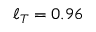Convert formula to latex. <formula><loc_0><loc_0><loc_500><loc_500>\ell _ { T } = 0 . 9 6</formula> 